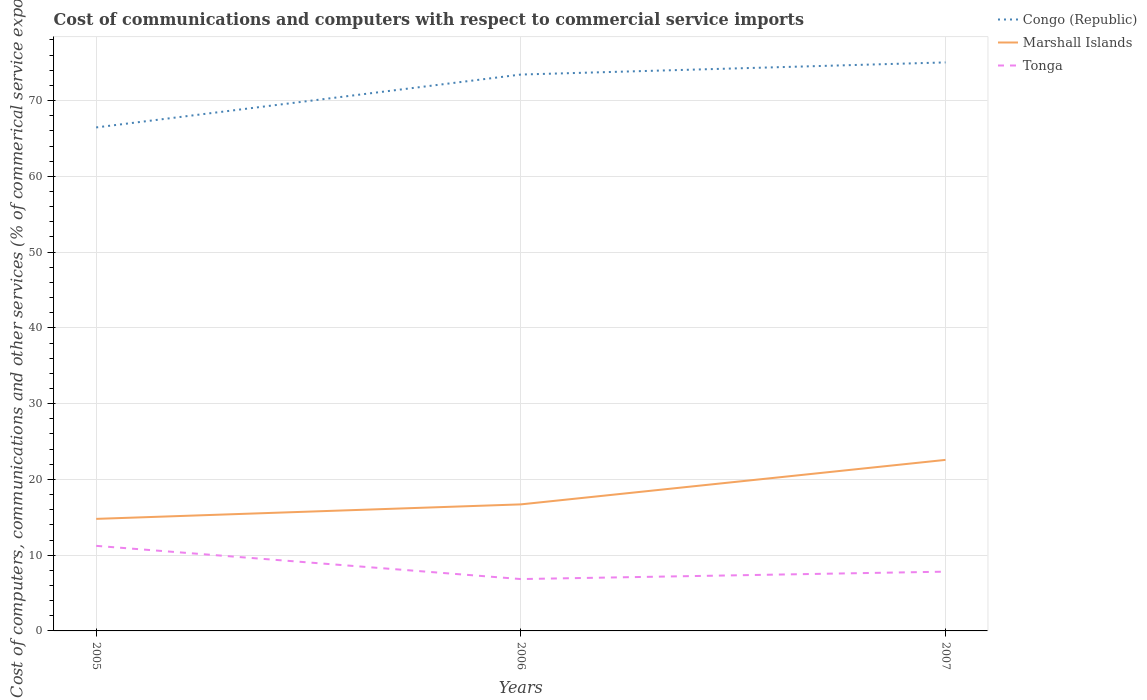Is the number of lines equal to the number of legend labels?
Your response must be concise. Yes. Across all years, what is the maximum cost of communications and computers in Tonga?
Make the answer very short. 6.84. In which year was the cost of communications and computers in Tonga maximum?
Give a very brief answer. 2006. What is the total cost of communications and computers in Congo (Republic) in the graph?
Your answer should be compact. -8.58. What is the difference between the highest and the second highest cost of communications and computers in Marshall Islands?
Your answer should be very brief. 7.79. What is the difference between the highest and the lowest cost of communications and computers in Congo (Republic)?
Offer a terse response. 2. Is the cost of communications and computers in Tonga strictly greater than the cost of communications and computers in Congo (Republic) over the years?
Provide a succinct answer. Yes. How many years are there in the graph?
Keep it short and to the point. 3. Does the graph contain any zero values?
Make the answer very short. No. Does the graph contain grids?
Make the answer very short. Yes. Where does the legend appear in the graph?
Your answer should be very brief. Top right. What is the title of the graph?
Make the answer very short. Cost of communications and computers with respect to commercial service imports. What is the label or title of the X-axis?
Your response must be concise. Years. What is the label or title of the Y-axis?
Provide a short and direct response. Cost of computers, communications and other services (% of commerical service exports). What is the Cost of computers, communications and other services (% of commerical service exports) of Congo (Republic) in 2005?
Your answer should be very brief. 66.45. What is the Cost of computers, communications and other services (% of commerical service exports) of Marshall Islands in 2005?
Your answer should be very brief. 14.79. What is the Cost of computers, communications and other services (% of commerical service exports) in Tonga in 2005?
Ensure brevity in your answer.  11.23. What is the Cost of computers, communications and other services (% of commerical service exports) in Congo (Republic) in 2006?
Give a very brief answer. 73.43. What is the Cost of computers, communications and other services (% of commerical service exports) in Marshall Islands in 2006?
Provide a succinct answer. 16.7. What is the Cost of computers, communications and other services (% of commerical service exports) of Tonga in 2006?
Give a very brief answer. 6.84. What is the Cost of computers, communications and other services (% of commerical service exports) in Congo (Republic) in 2007?
Your answer should be very brief. 75.03. What is the Cost of computers, communications and other services (% of commerical service exports) of Marshall Islands in 2007?
Your answer should be very brief. 22.57. What is the Cost of computers, communications and other services (% of commerical service exports) in Tonga in 2007?
Provide a succinct answer. 7.82. Across all years, what is the maximum Cost of computers, communications and other services (% of commerical service exports) in Congo (Republic)?
Offer a terse response. 75.03. Across all years, what is the maximum Cost of computers, communications and other services (% of commerical service exports) of Marshall Islands?
Provide a succinct answer. 22.57. Across all years, what is the maximum Cost of computers, communications and other services (% of commerical service exports) in Tonga?
Provide a succinct answer. 11.23. Across all years, what is the minimum Cost of computers, communications and other services (% of commerical service exports) of Congo (Republic)?
Keep it short and to the point. 66.45. Across all years, what is the minimum Cost of computers, communications and other services (% of commerical service exports) of Marshall Islands?
Provide a short and direct response. 14.79. Across all years, what is the minimum Cost of computers, communications and other services (% of commerical service exports) of Tonga?
Give a very brief answer. 6.84. What is the total Cost of computers, communications and other services (% of commerical service exports) of Congo (Republic) in the graph?
Your answer should be compact. 214.92. What is the total Cost of computers, communications and other services (% of commerical service exports) in Marshall Islands in the graph?
Keep it short and to the point. 54.06. What is the total Cost of computers, communications and other services (% of commerical service exports) in Tonga in the graph?
Your answer should be very brief. 25.9. What is the difference between the Cost of computers, communications and other services (% of commerical service exports) of Congo (Republic) in 2005 and that in 2006?
Offer a very short reply. -6.98. What is the difference between the Cost of computers, communications and other services (% of commerical service exports) in Marshall Islands in 2005 and that in 2006?
Keep it short and to the point. -1.91. What is the difference between the Cost of computers, communications and other services (% of commerical service exports) of Tonga in 2005 and that in 2006?
Provide a short and direct response. 4.38. What is the difference between the Cost of computers, communications and other services (% of commerical service exports) in Congo (Republic) in 2005 and that in 2007?
Ensure brevity in your answer.  -8.58. What is the difference between the Cost of computers, communications and other services (% of commerical service exports) of Marshall Islands in 2005 and that in 2007?
Offer a very short reply. -7.79. What is the difference between the Cost of computers, communications and other services (% of commerical service exports) of Tonga in 2005 and that in 2007?
Give a very brief answer. 3.41. What is the difference between the Cost of computers, communications and other services (% of commerical service exports) in Congo (Republic) in 2006 and that in 2007?
Provide a succinct answer. -1.6. What is the difference between the Cost of computers, communications and other services (% of commerical service exports) of Marshall Islands in 2006 and that in 2007?
Offer a very short reply. -5.87. What is the difference between the Cost of computers, communications and other services (% of commerical service exports) of Tonga in 2006 and that in 2007?
Offer a very short reply. -0.98. What is the difference between the Cost of computers, communications and other services (% of commerical service exports) of Congo (Republic) in 2005 and the Cost of computers, communications and other services (% of commerical service exports) of Marshall Islands in 2006?
Your answer should be very brief. 49.75. What is the difference between the Cost of computers, communications and other services (% of commerical service exports) in Congo (Republic) in 2005 and the Cost of computers, communications and other services (% of commerical service exports) in Tonga in 2006?
Your response must be concise. 59.61. What is the difference between the Cost of computers, communications and other services (% of commerical service exports) in Marshall Islands in 2005 and the Cost of computers, communications and other services (% of commerical service exports) in Tonga in 2006?
Keep it short and to the point. 7.94. What is the difference between the Cost of computers, communications and other services (% of commerical service exports) of Congo (Republic) in 2005 and the Cost of computers, communications and other services (% of commerical service exports) of Marshall Islands in 2007?
Provide a short and direct response. 43.88. What is the difference between the Cost of computers, communications and other services (% of commerical service exports) of Congo (Republic) in 2005 and the Cost of computers, communications and other services (% of commerical service exports) of Tonga in 2007?
Keep it short and to the point. 58.63. What is the difference between the Cost of computers, communications and other services (% of commerical service exports) in Marshall Islands in 2005 and the Cost of computers, communications and other services (% of commerical service exports) in Tonga in 2007?
Your answer should be compact. 6.96. What is the difference between the Cost of computers, communications and other services (% of commerical service exports) of Congo (Republic) in 2006 and the Cost of computers, communications and other services (% of commerical service exports) of Marshall Islands in 2007?
Give a very brief answer. 50.86. What is the difference between the Cost of computers, communications and other services (% of commerical service exports) of Congo (Republic) in 2006 and the Cost of computers, communications and other services (% of commerical service exports) of Tonga in 2007?
Give a very brief answer. 65.61. What is the difference between the Cost of computers, communications and other services (% of commerical service exports) of Marshall Islands in 2006 and the Cost of computers, communications and other services (% of commerical service exports) of Tonga in 2007?
Provide a succinct answer. 8.88. What is the average Cost of computers, communications and other services (% of commerical service exports) of Congo (Republic) per year?
Offer a terse response. 71.64. What is the average Cost of computers, communications and other services (% of commerical service exports) in Marshall Islands per year?
Provide a succinct answer. 18.02. What is the average Cost of computers, communications and other services (% of commerical service exports) in Tonga per year?
Your response must be concise. 8.63. In the year 2005, what is the difference between the Cost of computers, communications and other services (% of commerical service exports) in Congo (Republic) and Cost of computers, communications and other services (% of commerical service exports) in Marshall Islands?
Provide a succinct answer. 51.66. In the year 2005, what is the difference between the Cost of computers, communications and other services (% of commerical service exports) of Congo (Republic) and Cost of computers, communications and other services (% of commerical service exports) of Tonga?
Provide a succinct answer. 55.22. In the year 2005, what is the difference between the Cost of computers, communications and other services (% of commerical service exports) in Marshall Islands and Cost of computers, communications and other services (% of commerical service exports) in Tonga?
Your response must be concise. 3.56. In the year 2006, what is the difference between the Cost of computers, communications and other services (% of commerical service exports) of Congo (Republic) and Cost of computers, communications and other services (% of commerical service exports) of Marshall Islands?
Provide a succinct answer. 56.73. In the year 2006, what is the difference between the Cost of computers, communications and other services (% of commerical service exports) of Congo (Republic) and Cost of computers, communications and other services (% of commerical service exports) of Tonga?
Ensure brevity in your answer.  66.59. In the year 2006, what is the difference between the Cost of computers, communications and other services (% of commerical service exports) of Marshall Islands and Cost of computers, communications and other services (% of commerical service exports) of Tonga?
Ensure brevity in your answer.  9.86. In the year 2007, what is the difference between the Cost of computers, communications and other services (% of commerical service exports) in Congo (Republic) and Cost of computers, communications and other services (% of commerical service exports) in Marshall Islands?
Make the answer very short. 52.46. In the year 2007, what is the difference between the Cost of computers, communications and other services (% of commerical service exports) in Congo (Republic) and Cost of computers, communications and other services (% of commerical service exports) in Tonga?
Your response must be concise. 67.21. In the year 2007, what is the difference between the Cost of computers, communications and other services (% of commerical service exports) of Marshall Islands and Cost of computers, communications and other services (% of commerical service exports) of Tonga?
Ensure brevity in your answer.  14.75. What is the ratio of the Cost of computers, communications and other services (% of commerical service exports) in Congo (Republic) in 2005 to that in 2006?
Your response must be concise. 0.9. What is the ratio of the Cost of computers, communications and other services (% of commerical service exports) in Marshall Islands in 2005 to that in 2006?
Offer a very short reply. 0.89. What is the ratio of the Cost of computers, communications and other services (% of commerical service exports) in Tonga in 2005 to that in 2006?
Your answer should be compact. 1.64. What is the ratio of the Cost of computers, communications and other services (% of commerical service exports) in Congo (Republic) in 2005 to that in 2007?
Your answer should be compact. 0.89. What is the ratio of the Cost of computers, communications and other services (% of commerical service exports) in Marshall Islands in 2005 to that in 2007?
Make the answer very short. 0.66. What is the ratio of the Cost of computers, communications and other services (% of commerical service exports) of Tonga in 2005 to that in 2007?
Make the answer very short. 1.44. What is the ratio of the Cost of computers, communications and other services (% of commerical service exports) of Congo (Republic) in 2006 to that in 2007?
Give a very brief answer. 0.98. What is the ratio of the Cost of computers, communications and other services (% of commerical service exports) of Marshall Islands in 2006 to that in 2007?
Give a very brief answer. 0.74. What is the ratio of the Cost of computers, communications and other services (% of commerical service exports) in Tonga in 2006 to that in 2007?
Offer a very short reply. 0.87. What is the difference between the highest and the second highest Cost of computers, communications and other services (% of commerical service exports) of Congo (Republic)?
Provide a short and direct response. 1.6. What is the difference between the highest and the second highest Cost of computers, communications and other services (% of commerical service exports) of Marshall Islands?
Keep it short and to the point. 5.87. What is the difference between the highest and the second highest Cost of computers, communications and other services (% of commerical service exports) in Tonga?
Your answer should be compact. 3.41. What is the difference between the highest and the lowest Cost of computers, communications and other services (% of commerical service exports) in Congo (Republic)?
Give a very brief answer. 8.58. What is the difference between the highest and the lowest Cost of computers, communications and other services (% of commerical service exports) of Marshall Islands?
Offer a terse response. 7.79. What is the difference between the highest and the lowest Cost of computers, communications and other services (% of commerical service exports) in Tonga?
Offer a very short reply. 4.38. 